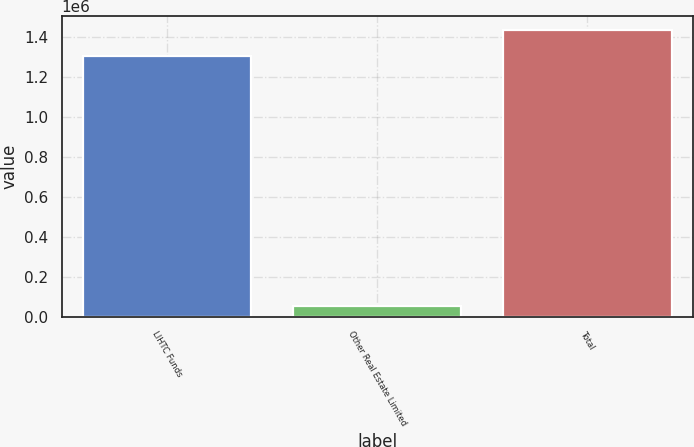Convert chart to OTSL. <chart><loc_0><loc_0><loc_500><loc_500><bar_chart><fcel>LIHTC Funds<fcel>Other Real Estate Limited<fcel>Total<nl><fcel>1.3035e+06<fcel>51166<fcel>1.43385e+06<nl></chart> 